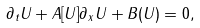<formula> <loc_0><loc_0><loc_500><loc_500>\partial _ { t } U + A [ U ] \partial _ { x } U + B ( U ) = 0 ,</formula> 